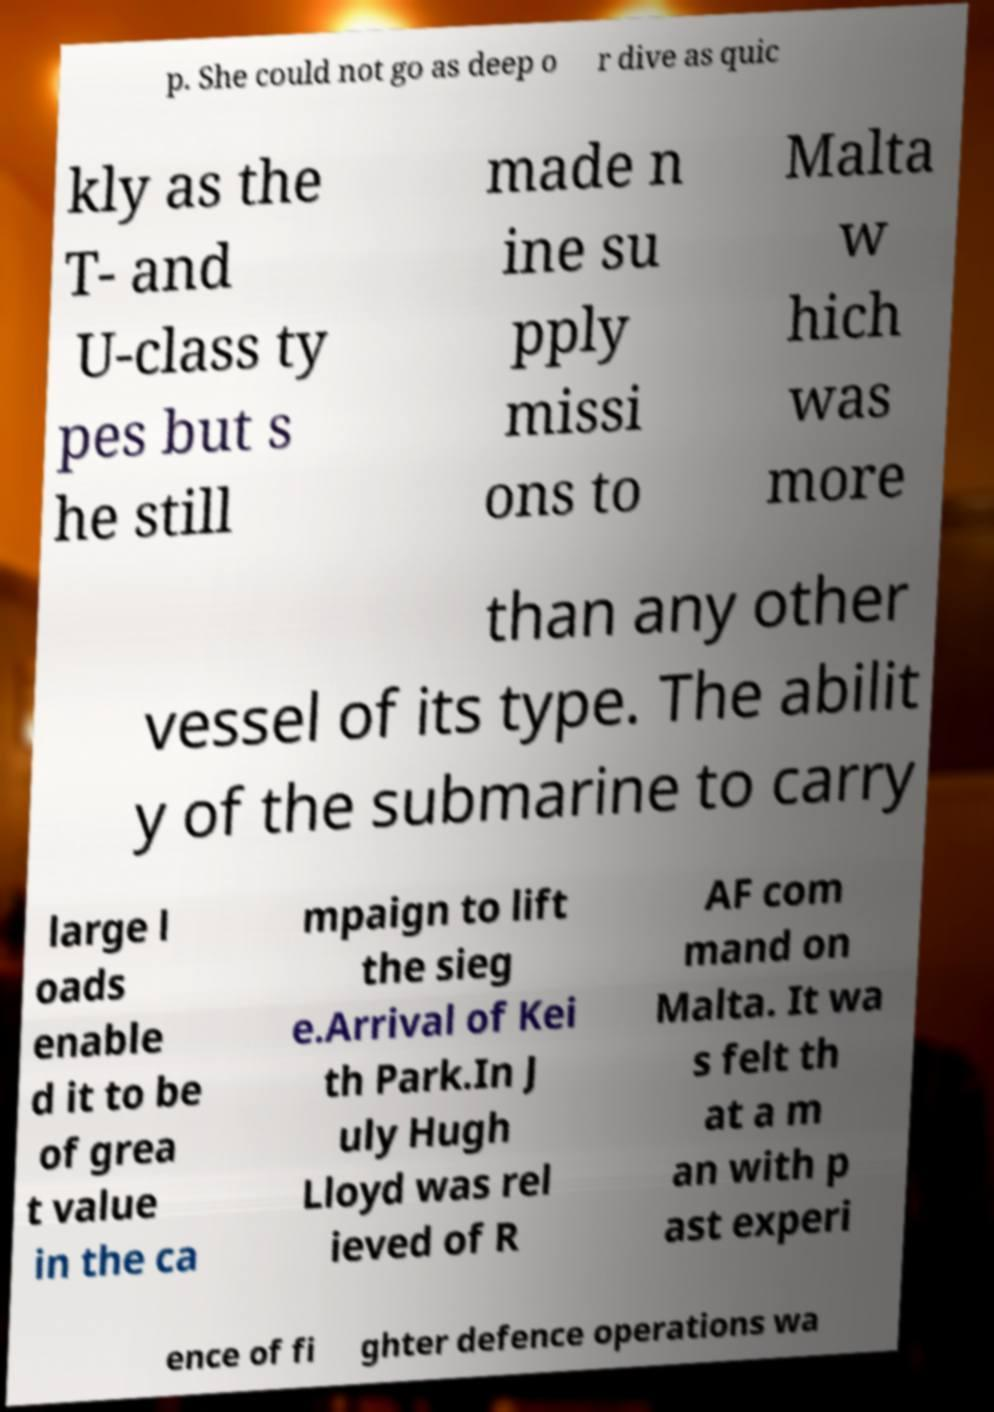There's text embedded in this image that I need extracted. Can you transcribe it verbatim? p. She could not go as deep o r dive as quic kly as the T- and U-class ty pes but s he still made n ine su pply missi ons to Malta w hich was more than any other vessel of its type. The abilit y of the submarine to carry large l oads enable d it to be of grea t value in the ca mpaign to lift the sieg e.Arrival of Kei th Park.In J uly Hugh Lloyd was rel ieved of R AF com mand on Malta. It wa s felt th at a m an with p ast experi ence of fi ghter defence operations wa 